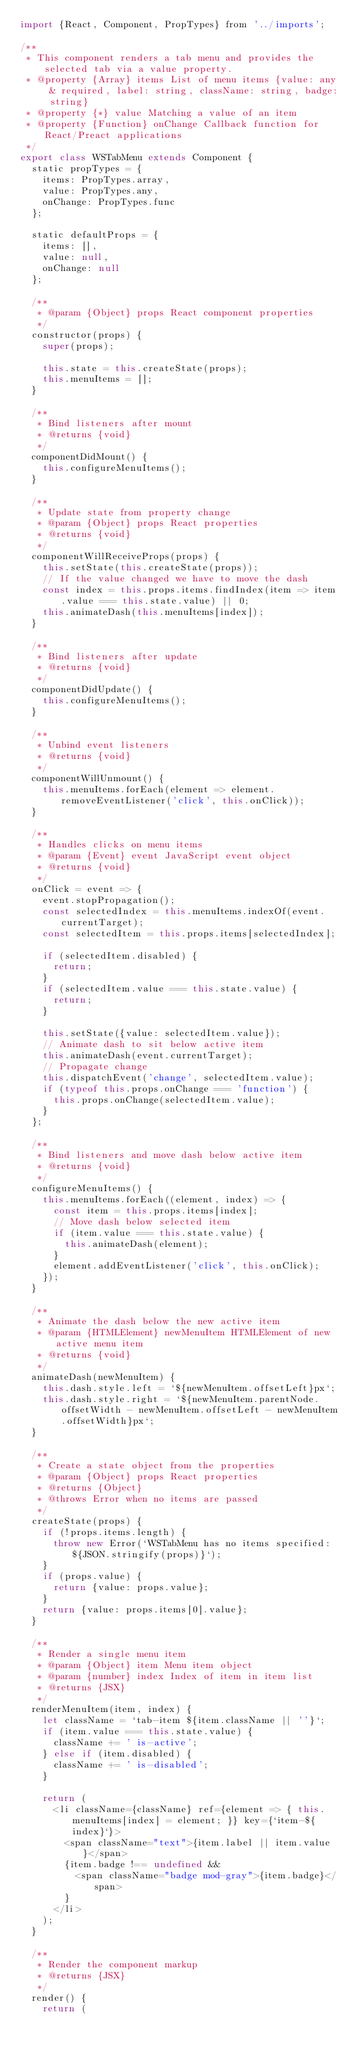Convert code to text. <code><loc_0><loc_0><loc_500><loc_500><_JavaScript_>import {React, Component, PropTypes} from '../imports';

/**
 * This component renders a tab menu and provides the selected tab via a value property.
 * @property {Array} items List of menu items {value: any & required, label: string, className: string, badge: string}
 * @property {*} value Matching a value of an item
 * @property {Function} onChange Callback function for React/Preact applications
 */
export class WSTabMenu extends Component {
  static propTypes = {
    items: PropTypes.array,
    value: PropTypes.any,
    onChange: PropTypes.func
  };

  static defaultProps = {
    items: [],
    value: null,
    onChange: null
  };

  /**
   * @param {Object} props React component properties
   */
  constructor(props) {
    super(props);

    this.state = this.createState(props);
    this.menuItems = [];
  }

  /**
   * Bind listeners after mount
   * @returns {void}
   */
  componentDidMount() {
    this.configureMenuItems();
  }

  /**
   * Update state from property change
   * @param {Object} props React properties
   * @returns {void}
   */
  componentWillReceiveProps(props) {
    this.setState(this.createState(props));
    // If the value changed we have to move the dash
    const index = this.props.items.findIndex(item => item.value === this.state.value) || 0;
    this.animateDash(this.menuItems[index]);
  }

  /**
   * Bind listeners after update
   * @returns {void}
   */
  componentDidUpdate() {
    this.configureMenuItems();
  }

  /**
   * Unbind event listeners
   * @returns {void}
   */
  componentWillUnmount() {
    this.menuItems.forEach(element => element.removeEventListener('click', this.onClick));
  }

  /**
   * Handles clicks on menu items
   * @param {Event} event JavaScript event object
   * @returns {void}
   */
  onClick = event => {
    event.stopPropagation();
    const selectedIndex = this.menuItems.indexOf(event.currentTarget);
    const selectedItem = this.props.items[selectedIndex];

    if (selectedItem.disabled) {
      return;
    }
    if (selectedItem.value === this.state.value) {
      return;
    }

    this.setState({value: selectedItem.value});
    // Animate dash to sit below active item
    this.animateDash(event.currentTarget);
    // Propagate change
    this.dispatchEvent('change', selectedItem.value);
    if (typeof this.props.onChange === 'function') {
      this.props.onChange(selectedItem.value);
    }
  };

  /**
   * Bind listeners and move dash below active item
   * @returns {void}
   */
  configureMenuItems() {
    this.menuItems.forEach((element, index) => {
      const item = this.props.items[index];
      // Move dash below selected item
      if (item.value === this.state.value) {
        this.animateDash(element);
      }
      element.addEventListener('click', this.onClick);
    });
  }

  /**
   * Animate the dash below the new active item
   * @param {HTMLElement} newMenuItem HTMLElement of new active menu item
   * @returns {void}
   */
  animateDash(newMenuItem) {
    this.dash.style.left = `${newMenuItem.offsetLeft}px`;
    this.dash.style.right = `${newMenuItem.parentNode.offsetWidth - newMenuItem.offsetLeft - newMenuItem.offsetWidth}px`;
  }

  /**
   * Create a state object from the properties
   * @param {Object} props React properties
   * @returns {Object}
   * @throws Error when no items are passed
   */
  createState(props) {
    if (!props.items.length) {
      throw new Error(`WSTabMenu has no items specified: ${JSON.stringify(props)}`);
    }
    if (props.value) {
      return {value: props.value};
    }
    return {value: props.items[0].value};
  }

  /**
   * Render a single menu item
   * @param {Object} item Menu item object
   * @param {number} index Index of item in item list
   * @returns {JSX}
   */
  renderMenuItem(item, index) {
    let className = `tab-item ${item.className || ''}`;
    if (item.value === this.state.value) {
      className += ' is-active';
    } else if (item.disabled) {
      className += ' is-disabled';
    }

    return (
      <li className={className} ref={element => { this.menuItems[index] = element; }} key={`item-${index}`}>
        <span className="text">{item.label || item.value}</span>
        {item.badge !== undefined &&
          <span className="badge mod-gray">{item.badge}</span>
        }
      </li>
    );
  }

  /**
   * Render the component markup
   * @returns {JSX}
   */
  render() {
    return (</code> 